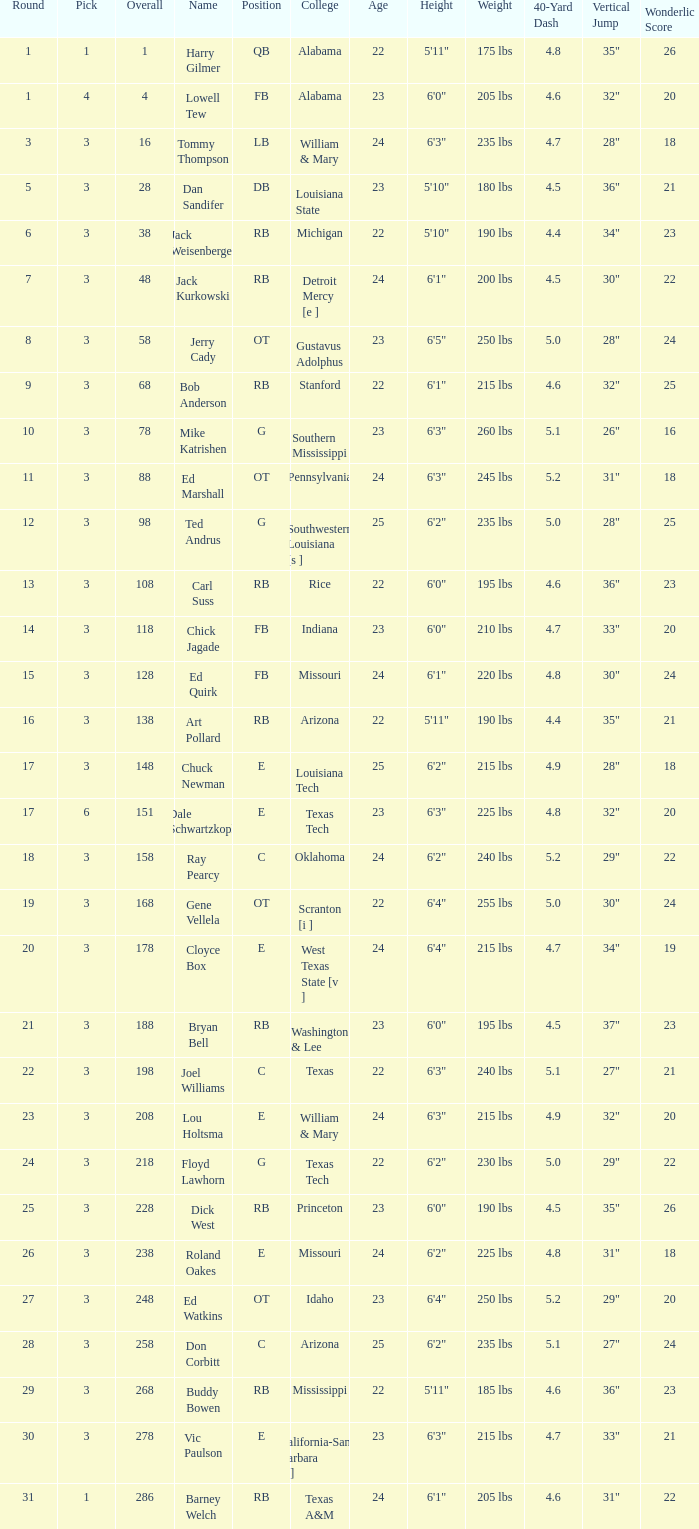Which Overall has a Name of bob anderson, and a Round smaller than 9? None. 